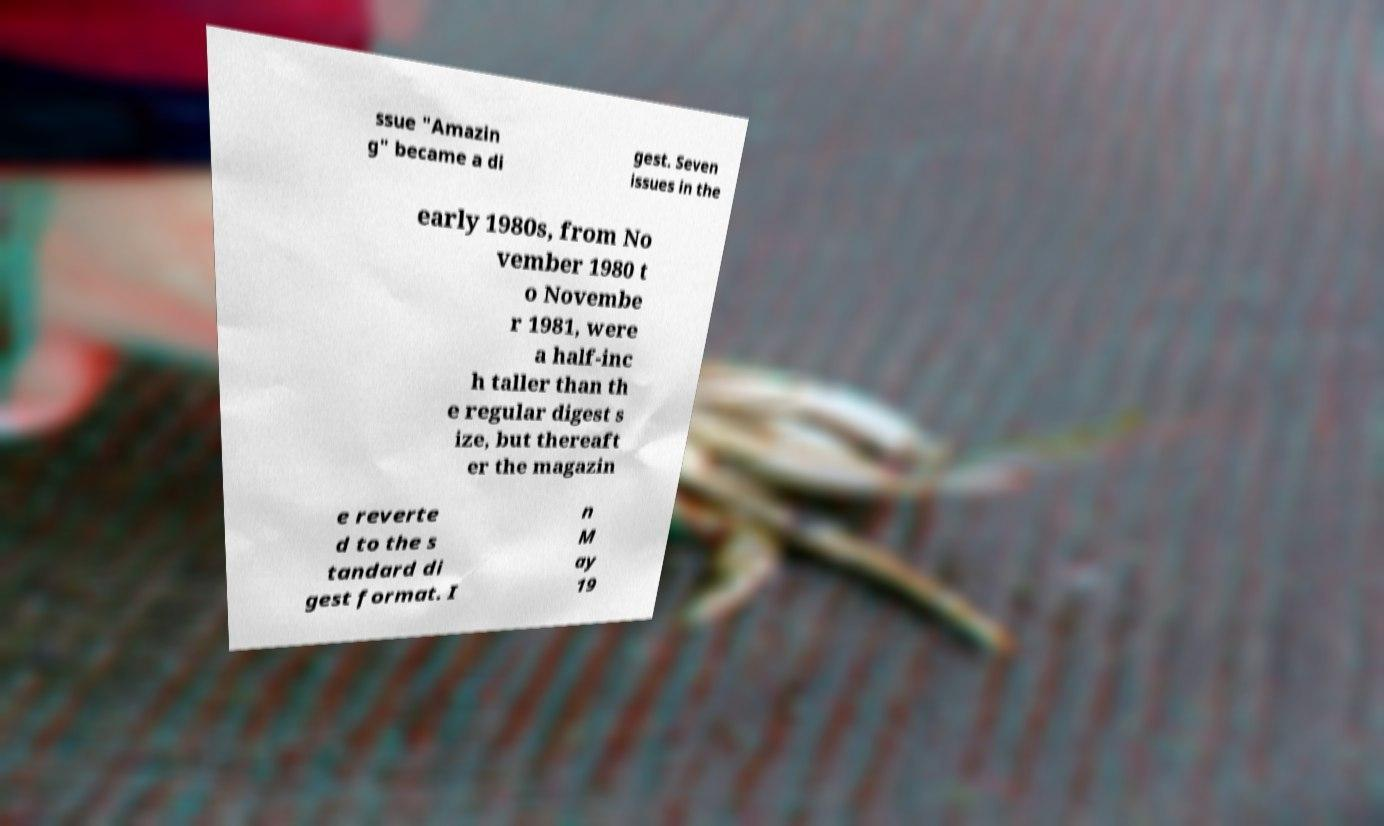Can you read and provide the text displayed in the image?This photo seems to have some interesting text. Can you extract and type it out for me? ssue "Amazin g" became a di gest. Seven issues in the early 1980s, from No vember 1980 t o Novembe r 1981, were a half-inc h taller than th e regular digest s ize, but thereaft er the magazin e reverte d to the s tandard di gest format. I n M ay 19 